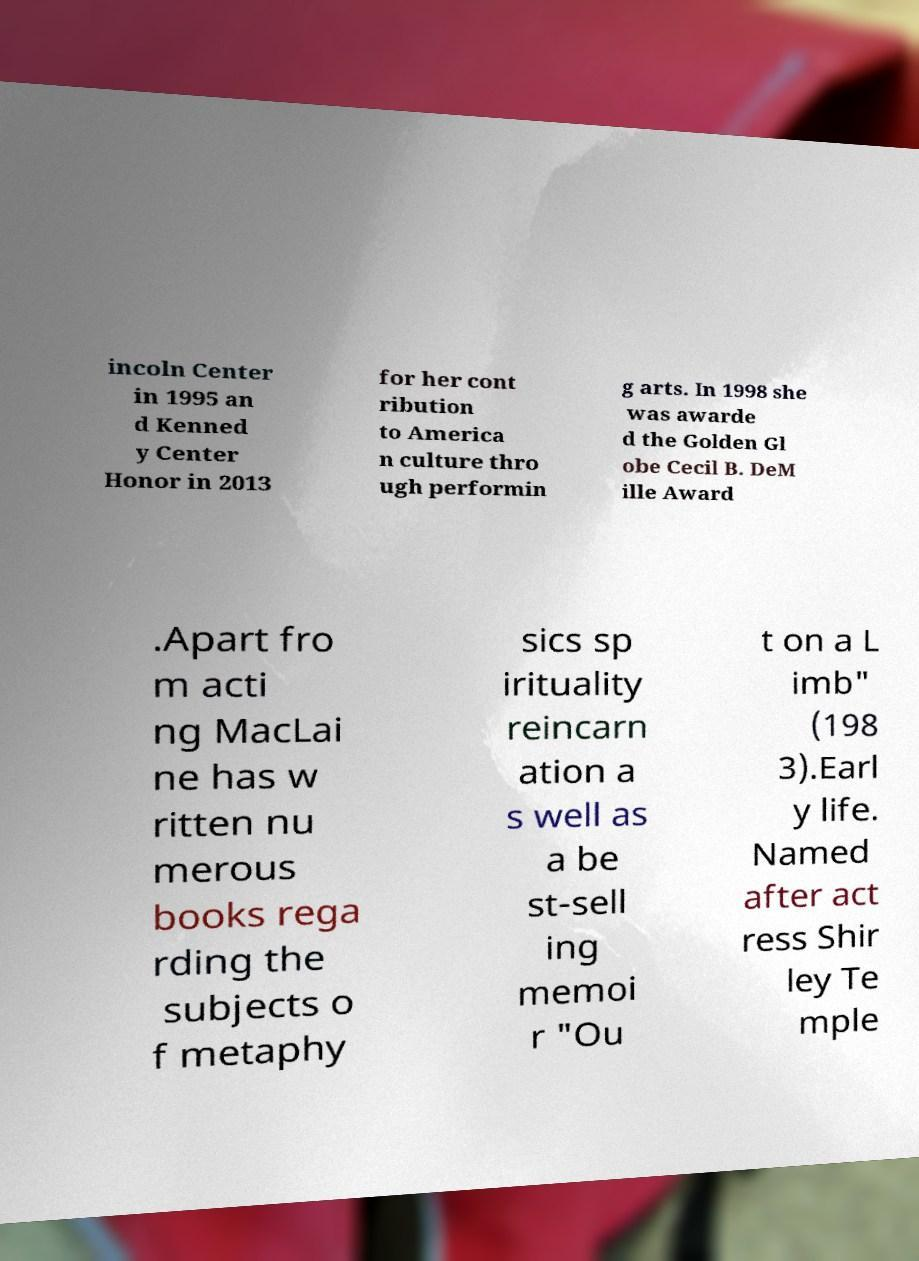There's text embedded in this image that I need extracted. Can you transcribe it verbatim? incoln Center in 1995 an d Kenned y Center Honor in 2013 for her cont ribution to America n culture thro ugh performin g arts. In 1998 she was awarde d the Golden Gl obe Cecil B. DeM ille Award .Apart fro m acti ng MacLai ne has w ritten nu merous books rega rding the subjects o f metaphy sics sp irituality reincarn ation a s well as a be st-sell ing memoi r "Ou t on a L imb" (198 3).Earl y life. Named after act ress Shir ley Te mple 